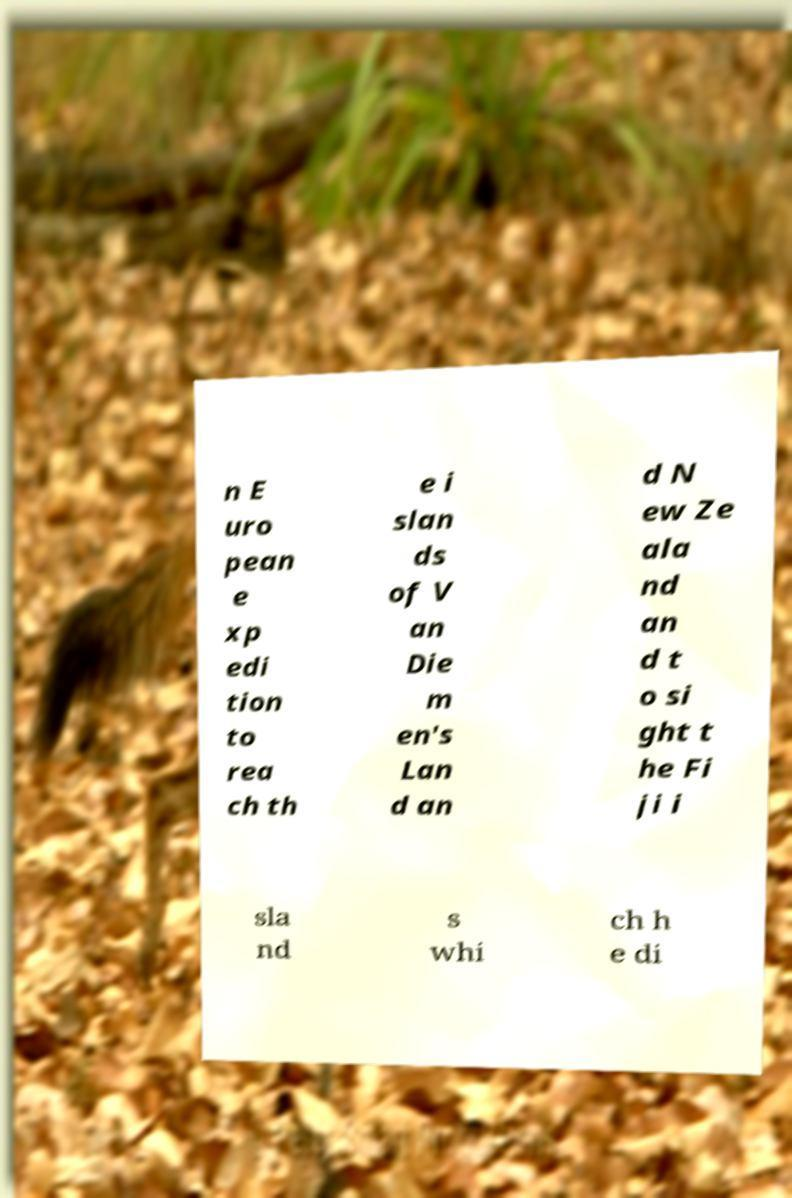What messages or text are displayed in this image? I need them in a readable, typed format. n E uro pean e xp edi tion to rea ch th e i slan ds of V an Die m en's Lan d an d N ew Ze ala nd an d t o si ght t he Fi ji i sla nd s whi ch h e di 